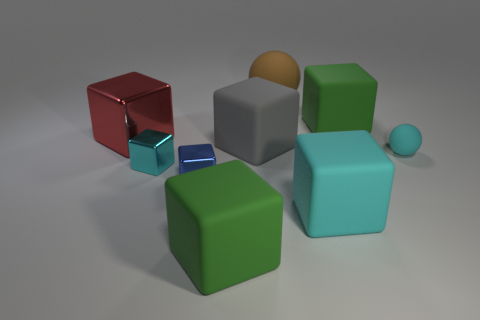Is the shape of the small blue object the same as the large green rubber thing behind the gray object?
Make the answer very short. Yes. What shape is the matte thing that is behind the green matte cube that is on the right side of the large green rubber cube left of the large ball?
Give a very brief answer. Sphere. What number of other objects are the same material as the small cyan cube?
Provide a short and direct response. 2. How many objects are either large green cubes behind the small matte thing or small cubes?
Offer a very short reply. 3. The small cyan object that is left of the large green rubber cube that is in front of the cyan shiny block is what shape?
Your answer should be compact. Cube. Does the large green thing that is right of the gray rubber thing have the same shape as the brown rubber thing?
Your answer should be very brief. No. There is a large cube to the right of the large cyan object; what is its color?
Offer a very short reply. Green. How many cubes are either large yellow rubber objects or large matte things?
Your answer should be compact. 4. There is a green block that is left of the large cube that is behind the big red shiny cube; what size is it?
Keep it short and to the point. Large. There is a tiny sphere; is its color the same as the tiny metallic thing that is to the left of the small blue thing?
Give a very brief answer. Yes. 